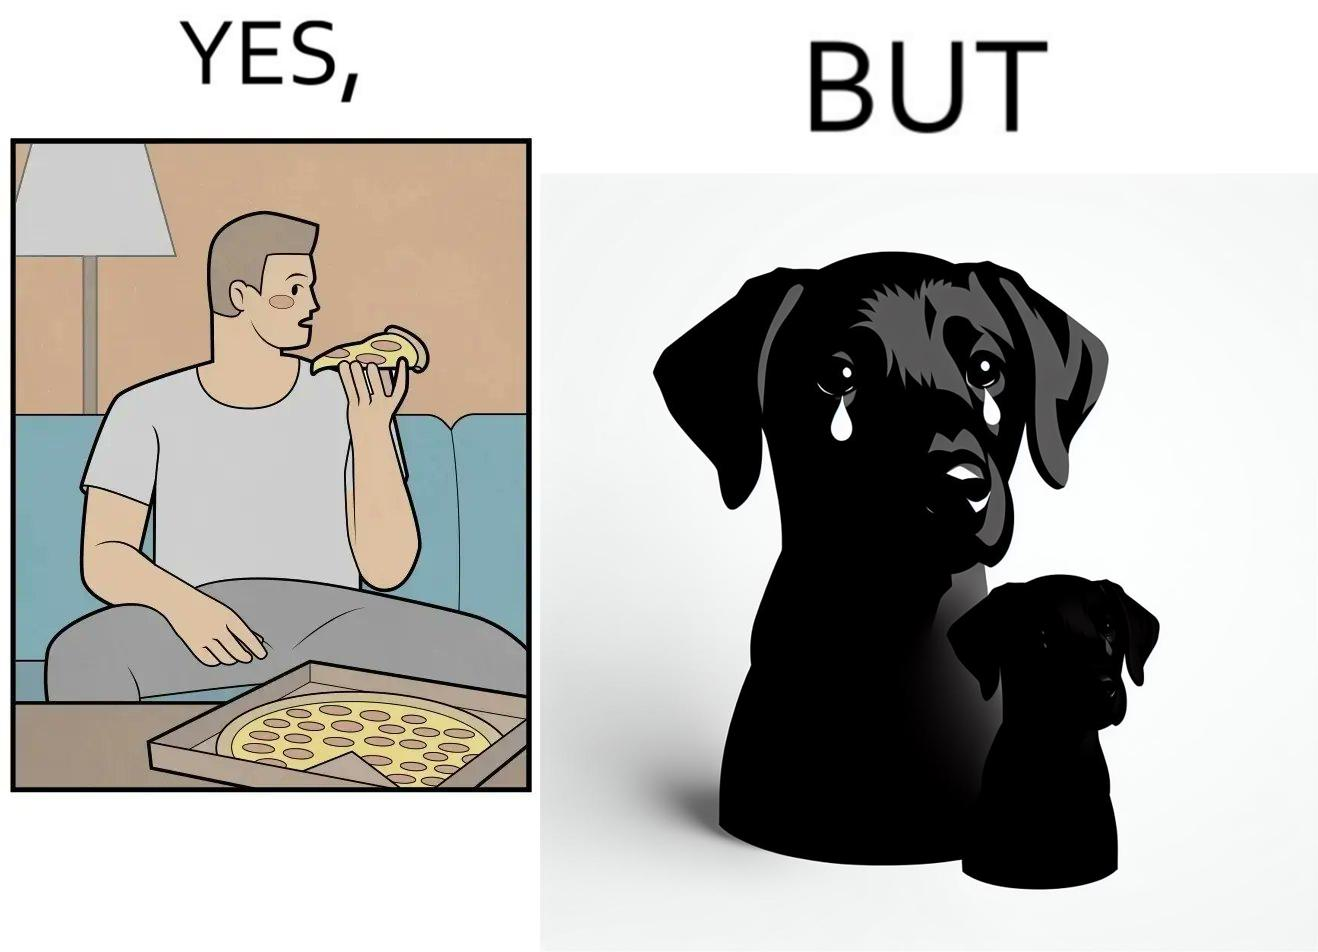Is there satirical content in this image? Yes, this image is satirical. 